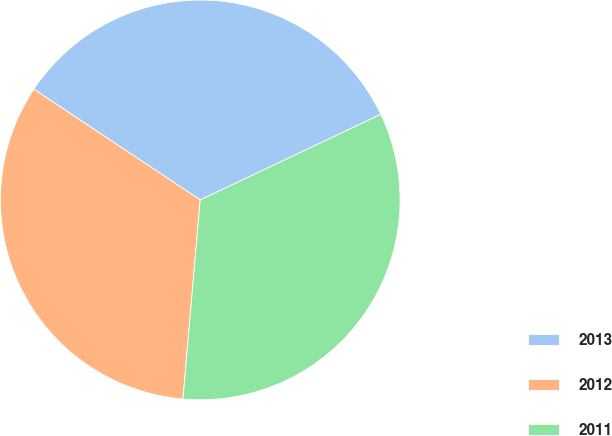Convert chart to OTSL. <chart><loc_0><loc_0><loc_500><loc_500><pie_chart><fcel>2013<fcel>2012<fcel>2011<nl><fcel>33.61%<fcel>32.97%<fcel>33.42%<nl></chart> 